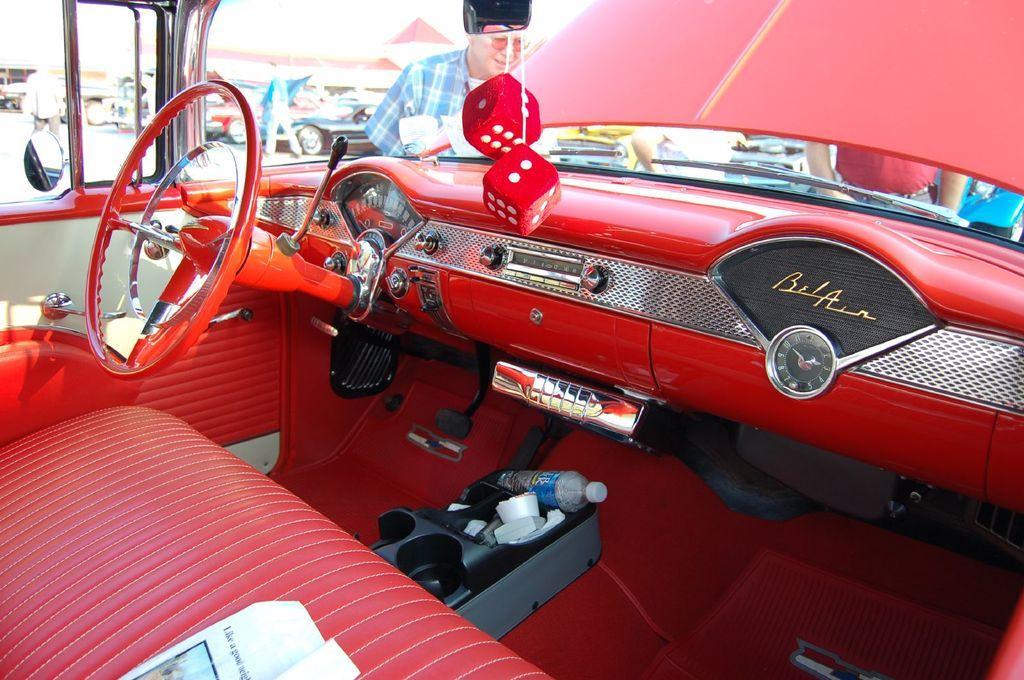In one or two sentences, can you explain what this image depicts? In this image I can see inside view of a red colour car. On the bottom side of the image I can see a bottle, few white colour things and on the top side of the image I can see two red colour dices. In the background I can see few people, number of cars and a building. I can also see this image is little bit blurry in the background and on the right side of the image I can see something is written on the car's dashboard. 